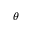<formula> <loc_0><loc_0><loc_500><loc_500>\theta</formula> 